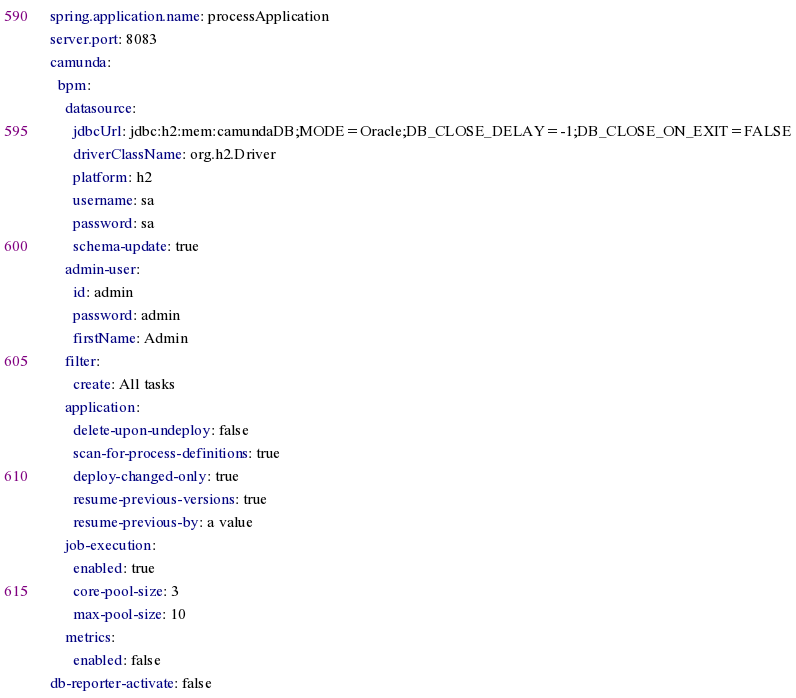Convert code to text. <code><loc_0><loc_0><loc_500><loc_500><_YAML_>spring.application.name: processApplication
server.port: 8083
camunda:
  bpm:
    datasource:
      jdbcUrl: jdbc:h2:mem:camundaDB;MODE=Oracle;DB_CLOSE_DELAY=-1;DB_CLOSE_ON_EXIT=FALSE
      driverClassName: org.h2.Driver
      platform: h2
      username: sa
      password: sa
      schema-update: true
    admin-user:
      id: admin
      password: admin
      firstName: Admin
    filter:
      create: All tasks
    application:
      delete-upon-undeploy: false
      scan-for-process-definitions: true
      deploy-changed-only: true
      resume-previous-versions: true
      resume-previous-by: a value
    job-execution:
      enabled: true
      core-pool-size: 3
      max-pool-size: 10
    metrics:
      enabled: false
db-reporter-activate: false</code> 